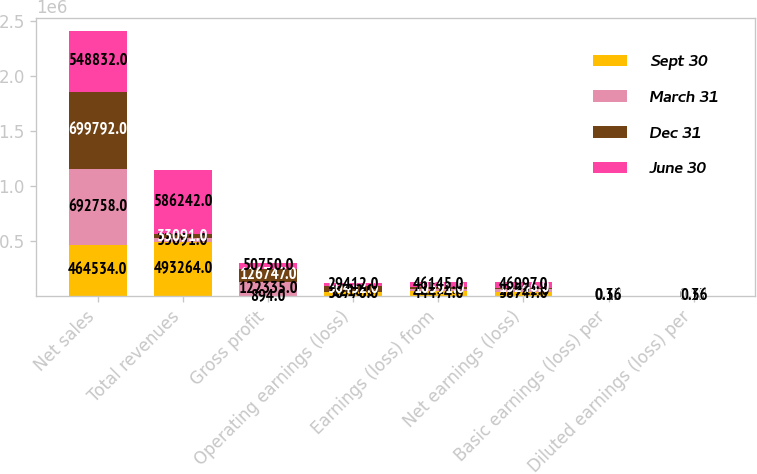<chart> <loc_0><loc_0><loc_500><loc_500><stacked_bar_chart><ecel><fcel>Net sales<fcel>Total revenues<fcel>Gross profit<fcel>Operating earnings (loss)<fcel>Earnings (loss) from<fcel>Net earnings (loss)<fcel>Basic earnings (loss) per<fcel>Diluted earnings (loss) per<nl><fcel>Sept 30<fcel>464534<fcel>493264<fcel>894<fcel>36770<fcel>44474<fcel>38747<fcel>0.35<fcel>0.35<nl><fcel>March 31<fcel>692758<fcel>33091<fcel>122335<fcel>1210<fcel>22515<fcel>23992<fcel>0.18<fcel>0.18<nl><fcel>Dec 31<fcel>699792<fcel>33091<fcel>126747<fcel>50432<fcel>10591<fcel>13246<fcel>0.08<fcel>0.08<nl><fcel>June 30<fcel>548832<fcel>586242<fcel>50750<fcel>29412<fcel>46145<fcel>46997<fcel>0.36<fcel>0.36<nl></chart> 